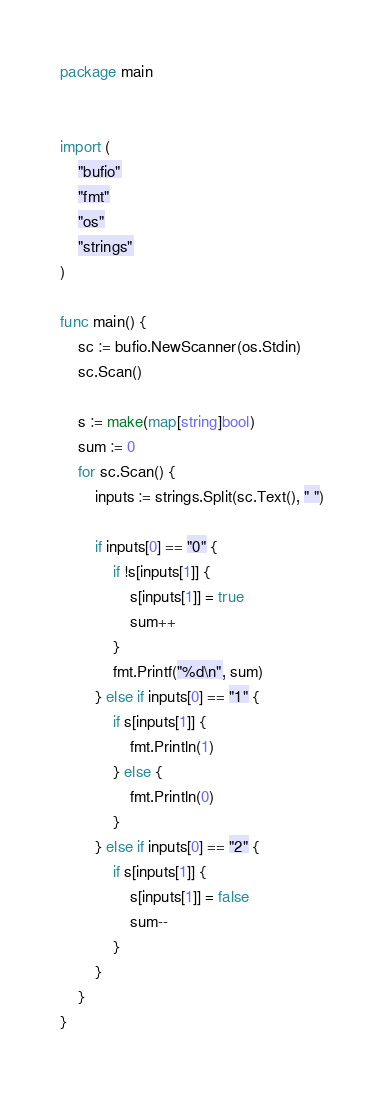Convert code to text. <code><loc_0><loc_0><loc_500><loc_500><_Go_>package main


import (
	"bufio"
	"fmt"
	"os"
	"strings"
)

func main() {
	sc := bufio.NewScanner(os.Stdin)
	sc.Scan()

	s := make(map[string]bool)
	sum := 0
	for sc.Scan() {
		inputs := strings.Split(sc.Text(), " ")

		if inputs[0] == "0" {
			if !s[inputs[1]] {
				s[inputs[1]] = true
				sum++
			}
			fmt.Printf("%d\n", sum)
		} else if inputs[0] == "1" {
			if s[inputs[1]] {
				fmt.Println(1)
			} else {
				fmt.Println(0)
			}
		} else if inputs[0] == "2" {
			if s[inputs[1]] {
				s[inputs[1]] = false
				sum--
			}
		}
	}
}

</code> 